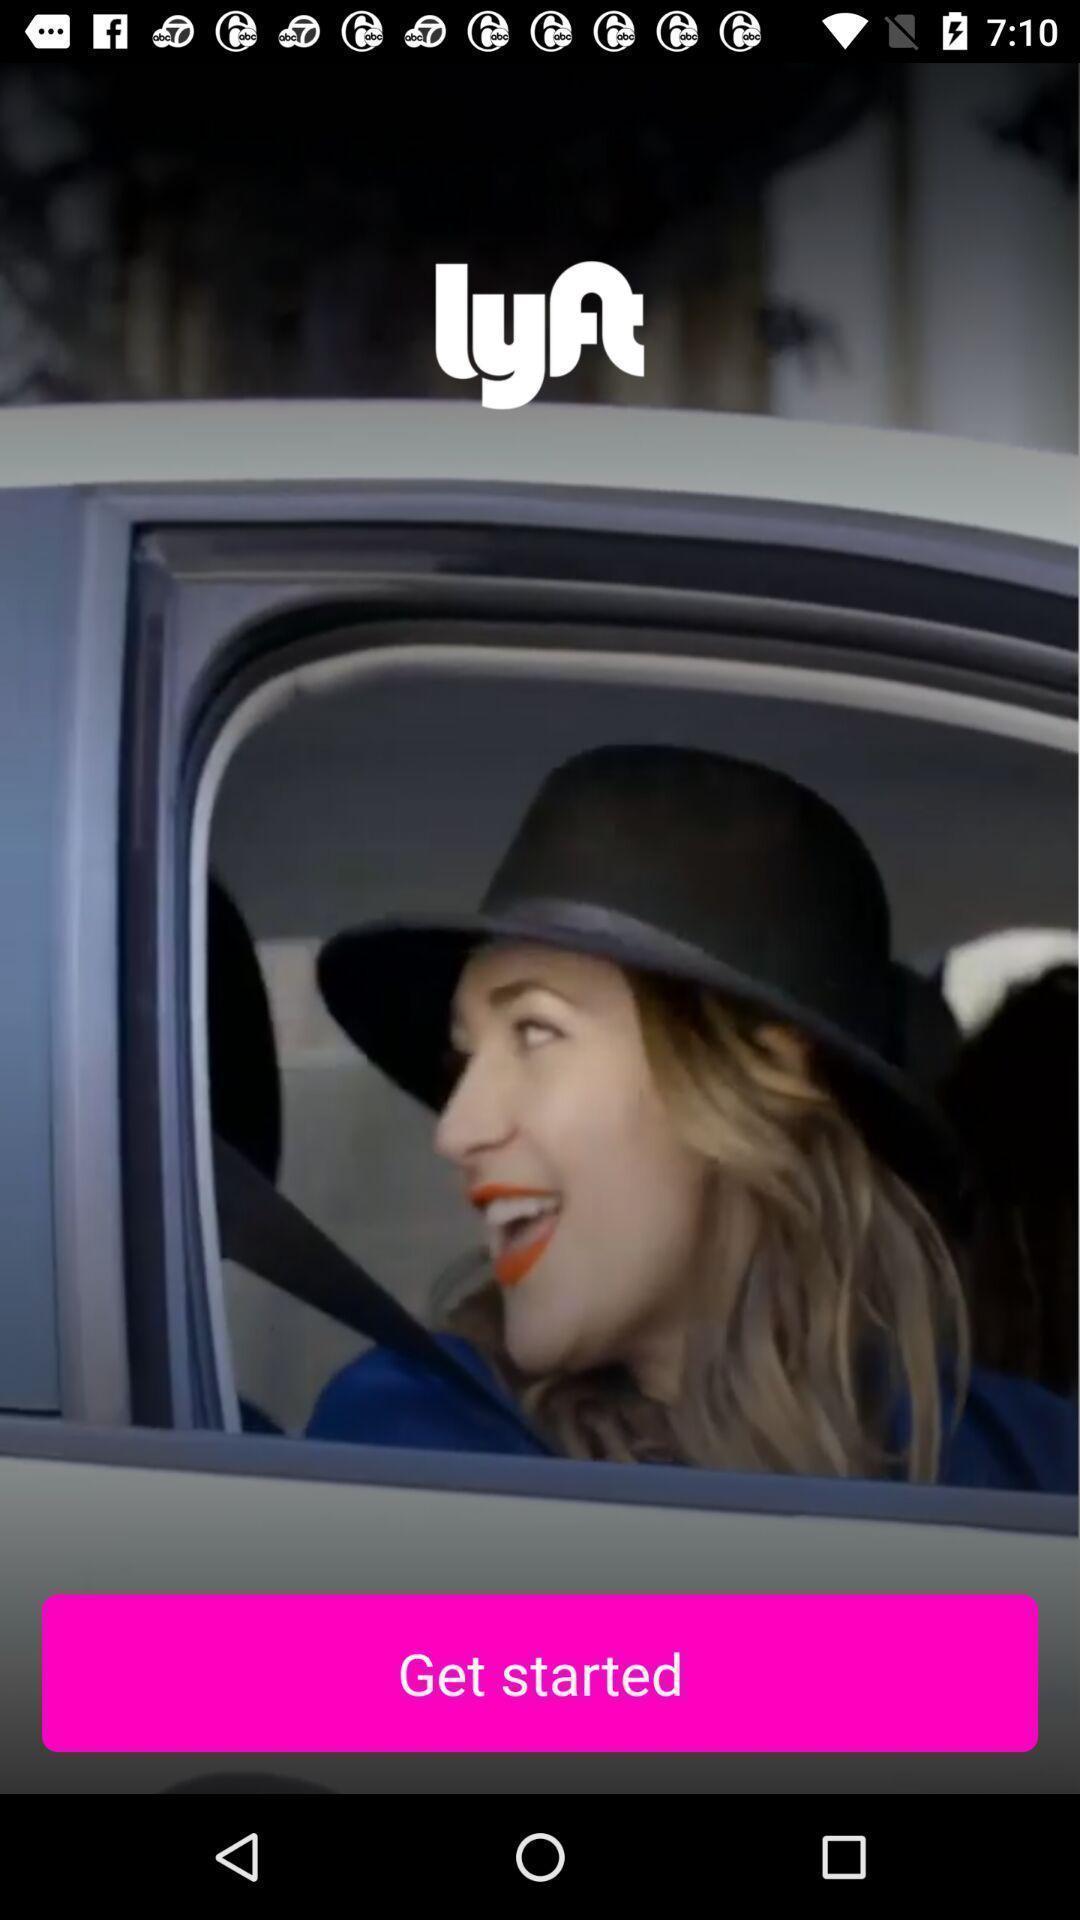Describe the key features of this screenshot. Welcome page to the application with option. 